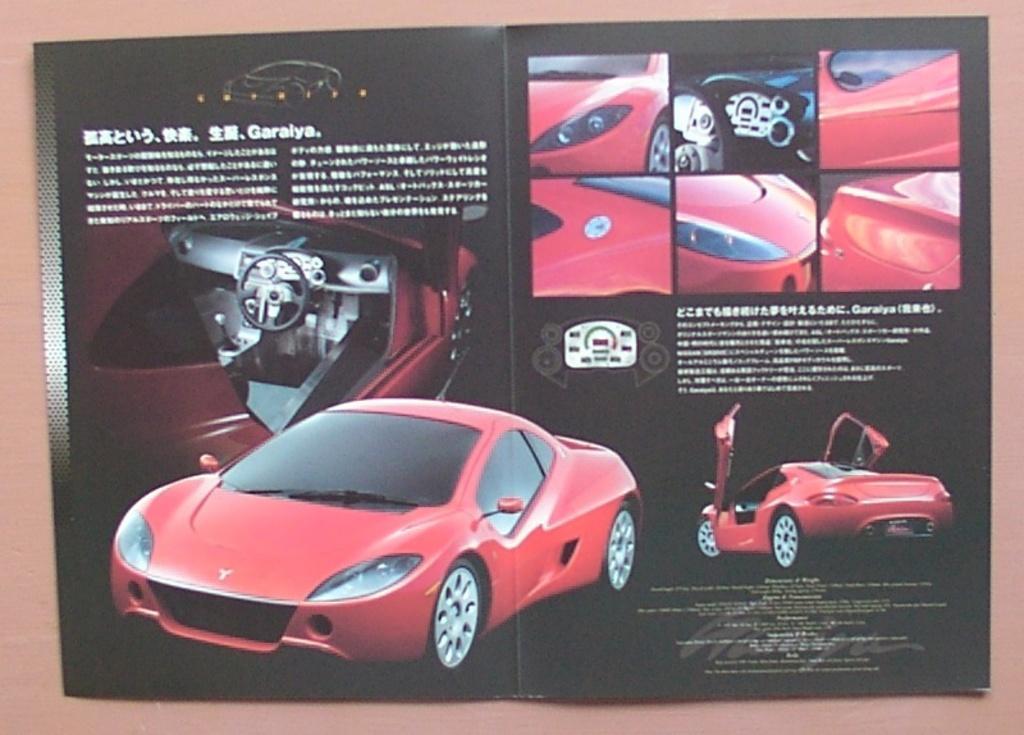How would you summarize this image in a sentence or two? This is a poster. On this poster we can see a car and its parts. 